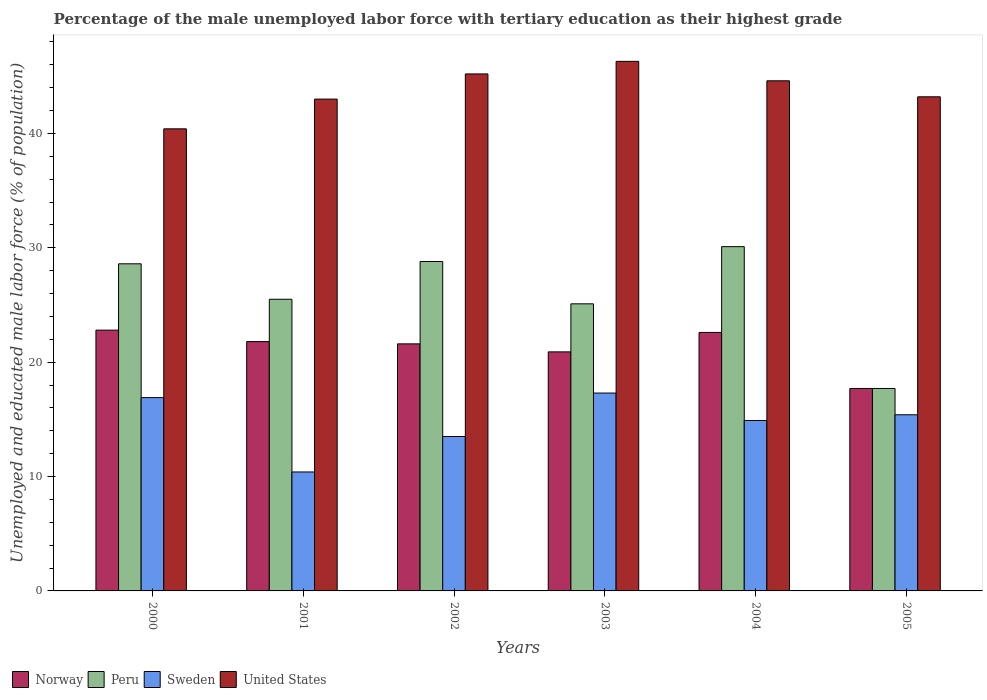How many groups of bars are there?
Ensure brevity in your answer.  6. Are the number of bars per tick equal to the number of legend labels?
Offer a terse response. Yes. Are the number of bars on each tick of the X-axis equal?
Provide a short and direct response. Yes. How many bars are there on the 1st tick from the left?
Ensure brevity in your answer.  4. How many bars are there on the 4th tick from the right?
Give a very brief answer. 4. What is the percentage of the unemployed male labor force with tertiary education in United States in 2000?
Offer a very short reply. 40.4. Across all years, what is the maximum percentage of the unemployed male labor force with tertiary education in Peru?
Provide a short and direct response. 30.1. Across all years, what is the minimum percentage of the unemployed male labor force with tertiary education in Sweden?
Provide a short and direct response. 10.4. What is the total percentage of the unemployed male labor force with tertiary education in Peru in the graph?
Your response must be concise. 155.8. What is the difference between the percentage of the unemployed male labor force with tertiary education in Sweden in 2001 and that in 2003?
Your answer should be very brief. -6.9. What is the difference between the percentage of the unemployed male labor force with tertiary education in Sweden in 2000 and the percentage of the unemployed male labor force with tertiary education in United States in 2002?
Your answer should be very brief. -28.3. What is the average percentage of the unemployed male labor force with tertiary education in United States per year?
Offer a very short reply. 43.78. In the year 2004, what is the difference between the percentage of the unemployed male labor force with tertiary education in Sweden and percentage of the unemployed male labor force with tertiary education in United States?
Make the answer very short. -29.7. In how many years, is the percentage of the unemployed male labor force with tertiary education in Peru greater than 26 %?
Provide a succinct answer. 3. What is the ratio of the percentage of the unemployed male labor force with tertiary education in Norway in 2000 to that in 2004?
Your answer should be very brief. 1.01. Is the difference between the percentage of the unemployed male labor force with tertiary education in Sweden in 2004 and 2005 greater than the difference between the percentage of the unemployed male labor force with tertiary education in United States in 2004 and 2005?
Offer a terse response. No. What is the difference between the highest and the second highest percentage of the unemployed male labor force with tertiary education in United States?
Provide a succinct answer. 1.1. What is the difference between the highest and the lowest percentage of the unemployed male labor force with tertiary education in United States?
Your answer should be compact. 5.9. In how many years, is the percentage of the unemployed male labor force with tertiary education in Peru greater than the average percentage of the unemployed male labor force with tertiary education in Peru taken over all years?
Your answer should be compact. 3. Is the sum of the percentage of the unemployed male labor force with tertiary education in Norway in 2001 and 2005 greater than the maximum percentage of the unemployed male labor force with tertiary education in United States across all years?
Your answer should be compact. No. Is it the case that in every year, the sum of the percentage of the unemployed male labor force with tertiary education in United States and percentage of the unemployed male labor force with tertiary education in Sweden is greater than the sum of percentage of the unemployed male labor force with tertiary education in Peru and percentage of the unemployed male labor force with tertiary education in Norway?
Ensure brevity in your answer.  No. What does the 1st bar from the left in 2002 represents?
Give a very brief answer. Norway. What does the 3rd bar from the right in 2002 represents?
Your answer should be compact. Peru. Is it the case that in every year, the sum of the percentage of the unemployed male labor force with tertiary education in Norway and percentage of the unemployed male labor force with tertiary education in United States is greater than the percentage of the unemployed male labor force with tertiary education in Peru?
Provide a succinct answer. Yes. How many bars are there?
Keep it short and to the point. 24. Are all the bars in the graph horizontal?
Ensure brevity in your answer.  No. How many years are there in the graph?
Offer a very short reply. 6. What is the difference between two consecutive major ticks on the Y-axis?
Provide a succinct answer. 10. Where does the legend appear in the graph?
Your response must be concise. Bottom left. How many legend labels are there?
Make the answer very short. 4. What is the title of the graph?
Offer a very short reply. Percentage of the male unemployed labor force with tertiary education as their highest grade. What is the label or title of the Y-axis?
Your answer should be compact. Unemployed and educated male labor force (% of population). What is the Unemployed and educated male labor force (% of population) in Norway in 2000?
Give a very brief answer. 22.8. What is the Unemployed and educated male labor force (% of population) in Peru in 2000?
Give a very brief answer. 28.6. What is the Unemployed and educated male labor force (% of population) of Sweden in 2000?
Ensure brevity in your answer.  16.9. What is the Unemployed and educated male labor force (% of population) of United States in 2000?
Ensure brevity in your answer.  40.4. What is the Unemployed and educated male labor force (% of population) of Norway in 2001?
Make the answer very short. 21.8. What is the Unemployed and educated male labor force (% of population) in Sweden in 2001?
Give a very brief answer. 10.4. What is the Unemployed and educated male labor force (% of population) in Norway in 2002?
Provide a short and direct response. 21.6. What is the Unemployed and educated male labor force (% of population) of Peru in 2002?
Provide a succinct answer. 28.8. What is the Unemployed and educated male labor force (% of population) in United States in 2002?
Your answer should be compact. 45.2. What is the Unemployed and educated male labor force (% of population) of Norway in 2003?
Offer a very short reply. 20.9. What is the Unemployed and educated male labor force (% of population) in Peru in 2003?
Your answer should be compact. 25.1. What is the Unemployed and educated male labor force (% of population) of Sweden in 2003?
Offer a terse response. 17.3. What is the Unemployed and educated male labor force (% of population) of United States in 2003?
Your answer should be compact. 46.3. What is the Unemployed and educated male labor force (% of population) of Norway in 2004?
Your response must be concise. 22.6. What is the Unemployed and educated male labor force (% of population) of Peru in 2004?
Provide a short and direct response. 30.1. What is the Unemployed and educated male labor force (% of population) of Sweden in 2004?
Your answer should be compact. 14.9. What is the Unemployed and educated male labor force (% of population) in United States in 2004?
Offer a very short reply. 44.6. What is the Unemployed and educated male labor force (% of population) of Norway in 2005?
Provide a succinct answer. 17.7. What is the Unemployed and educated male labor force (% of population) in Peru in 2005?
Your answer should be very brief. 17.7. What is the Unemployed and educated male labor force (% of population) in Sweden in 2005?
Your response must be concise. 15.4. What is the Unemployed and educated male labor force (% of population) in United States in 2005?
Give a very brief answer. 43.2. Across all years, what is the maximum Unemployed and educated male labor force (% of population) in Norway?
Provide a succinct answer. 22.8. Across all years, what is the maximum Unemployed and educated male labor force (% of population) of Peru?
Your answer should be very brief. 30.1. Across all years, what is the maximum Unemployed and educated male labor force (% of population) of Sweden?
Your response must be concise. 17.3. Across all years, what is the maximum Unemployed and educated male labor force (% of population) in United States?
Provide a succinct answer. 46.3. Across all years, what is the minimum Unemployed and educated male labor force (% of population) in Norway?
Your response must be concise. 17.7. Across all years, what is the minimum Unemployed and educated male labor force (% of population) in Peru?
Your answer should be very brief. 17.7. Across all years, what is the minimum Unemployed and educated male labor force (% of population) in Sweden?
Keep it short and to the point. 10.4. Across all years, what is the minimum Unemployed and educated male labor force (% of population) of United States?
Provide a succinct answer. 40.4. What is the total Unemployed and educated male labor force (% of population) in Norway in the graph?
Your answer should be compact. 127.4. What is the total Unemployed and educated male labor force (% of population) of Peru in the graph?
Offer a terse response. 155.8. What is the total Unemployed and educated male labor force (% of population) of Sweden in the graph?
Ensure brevity in your answer.  88.4. What is the total Unemployed and educated male labor force (% of population) in United States in the graph?
Keep it short and to the point. 262.7. What is the difference between the Unemployed and educated male labor force (% of population) in Sweden in 2000 and that in 2001?
Give a very brief answer. 6.5. What is the difference between the Unemployed and educated male labor force (% of population) in Peru in 2000 and that in 2002?
Offer a terse response. -0.2. What is the difference between the Unemployed and educated male labor force (% of population) of Sweden in 2000 and that in 2002?
Ensure brevity in your answer.  3.4. What is the difference between the Unemployed and educated male labor force (% of population) in United States in 2000 and that in 2002?
Your answer should be compact. -4.8. What is the difference between the Unemployed and educated male labor force (% of population) in Norway in 2000 and that in 2003?
Your answer should be compact. 1.9. What is the difference between the Unemployed and educated male labor force (% of population) of Peru in 2000 and that in 2003?
Give a very brief answer. 3.5. What is the difference between the Unemployed and educated male labor force (% of population) in United States in 2000 and that in 2003?
Provide a short and direct response. -5.9. What is the difference between the Unemployed and educated male labor force (% of population) of Peru in 2000 and that in 2005?
Provide a succinct answer. 10.9. What is the difference between the Unemployed and educated male labor force (% of population) of Sweden in 2000 and that in 2005?
Offer a very short reply. 1.5. What is the difference between the Unemployed and educated male labor force (% of population) of Norway in 2001 and that in 2002?
Offer a terse response. 0.2. What is the difference between the Unemployed and educated male labor force (% of population) in Peru in 2001 and that in 2002?
Your answer should be compact. -3.3. What is the difference between the Unemployed and educated male labor force (% of population) in Sweden in 2001 and that in 2002?
Make the answer very short. -3.1. What is the difference between the Unemployed and educated male labor force (% of population) in United States in 2001 and that in 2002?
Give a very brief answer. -2.2. What is the difference between the Unemployed and educated male labor force (% of population) in Norway in 2001 and that in 2003?
Offer a terse response. 0.9. What is the difference between the Unemployed and educated male labor force (% of population) of Sweden in 2001 and that in 2003?
Make the answer very short. -6.9. What is the difference between the Unemployed and educated male labor force (% of population) of Norway in 2001 and that in 2004?
Your answer should be compact. -0.8. What is the difference between the Unemployed and educated male labor force (% of population) of Sweden in 2001 and that in 2004?
Provide a succinct answer. -4.5. What is the difference between the Unemployed and educated male labor force (% of population) in Norway in 2001 and that in 2005?
Offer a very short reply. 4.1. What is the difference between the Unemployed and educated male labor force (% of population) in United States in 2001 and that in 2005?
Make the answer very short. -0.2. What is the difference between the Unemployed and educated male labor force (% of population) in Peru in 2002 and that in 2003?
Keep it short and to the point. 3.7. What is the difference between the Unemployed and educated male labor force (% of population) of Sweden in 2002 and that in 2003?
Your answer should be compact. -3.8. What is the difference between the Unemployed and educated male labor force (% of population) in United States in 2002 and that in 2003?
Provide a succinct answer. -1.1. What is the difference between the Unemployed and educated male labor force (% of population) in Sweden in 2002 and that in 2004?
Make the answer very short. -1.4. What is the difference between the Unemployed and educated male labor force (% of population) in United States in 2002 and that in 2004?
Provide a short and direct response. 0.6. What is the difference between the Unemployed and educated male labor force (% of population) of Norway in 2002 and that in 2005?
Offer a terse response. 3.9. What is the difference between the Unemployed and educated male labor force (% of population) of United States in 2002 and that in 2005?
Ensure brevity in your answer.  2. What is the difference between the Unemployed and educated male labor force (% of population) of Norway in 2003 and that in 2004?
Your answer should be compact. -1.7. What is the difference between the Unemployed and educated male labor force (% of population) of Sweden in 2003 and that in 2004?
Your answer should be compact. 2.4. What is the difference between the Unemployed and educated male labor force (% of population) of United States in 2003 and that in 2005?
Ensure brevity in your answer.  3.1. What is the difference between the Unemployed and educated male labor force (% of population) in Norway in 2004 and that in 2005?
Offer a terse response. 4.9. What is the difference between the Unemployed and educated male labor force (% of population) in Sweden in 2004 and that in 2005?
Ensure brevity in your answer.  -0.5. What is the difference between the Unemployed and educated male labor force (% of population) in Norway in 2000 and the Unemployed and educated male labor force (% of population) in Peru in 2001?
Provide a succinct answer. -2.7. What is the difference between the Unemployed and educated male labor force (% of population) of Norway in 2000 and the Unemployed and educated male labor force (% of population) of United States in 2001?
Your response must be concise. -20.2. What is the difference between the Unemployed and educated male labor force (% of population) of Peru in 2000 and the Unemployed and educated male labor force (% of population) of United States in 2001?
Offer a very short reply. -14.4. What is the difference between the Unemployed and educated male labor force (% of population) in Sweden in 2000 and the Unemployed and educated male labor force (% of population) in United States in 2001?
Make the answer very short. -26.1. What is the difference between the Unemployed and educated male labor force (% of population) of Norway in 2000 and the Unemployed and educated male labor force (% of population) of Peru in 2002?
Provide a succinct answer. -6. What is the difference between the Unemployed and educated male labor force (% of population) of Norway in 2000 and the Unemployed and educated male labor force (% of population) of Sweden in 2002?
Your answer should be very brief. 9.3. What is the difference between the Unemployed and educated male labor force (% of population) of Norway in 2000 and the Unemployed and educated male labor force (% of population) of United States in 2002?
Offer a very short reply. -22.4. What is the difference between the Unemployed and educated male labor force (% of population) of Peru in 2000 and the Unemployed and educated male labor force (% of population) of United States in 2002?
Your answer should be compact. -16.6. What is the difference between the Unemployed and educated male labor force (% of population) of Sweden in 2000 and the Unemployed and educated male labor force (% of population) of United States in 2002?
Give a very brief answer. -28.3. What is the difference between the Unemployed and educated male labor force (% of population) of Norway in 2000 and the Unemployed and educated male labor force (% of population) of Sweden in 2003?
Your response must be concise. 5.5. What is the difference between the Unemployed and educated male labor force (% of population) in Norway in 2000 and the Unemployed and educated male labor force (% of population) in United States in 2003?
Keep it short and to the point. -23.5. What is the difference between the Unemployed and educated male labor force (% of population) of Peru in 2000 and the Unemployed and educated male labor force (% of population) of United States in 2003?
Provide a succinct answer. -17.7. What is the difference between the Unemployed and educated male labor force (% of population) in Sweden in 2000 and the Unemployed and educated male labor force (% of population) in United States in 2003?
Provide a succinct answer. -29.4. What is the difference between the Unemployed and educated male labor force (% of population) of Norway in 2000 and the Unemployed and educated male labor force (% of population) of Sweden in 2004?
Make the answer very short. 7.9. What is the difference between the Unemployed and educated male labor force (% of population) in Norway in 2000 and the Unemployed and educated male labor force (% of population) in United States in 2004?
Make the answer very short. -21.8. What is the difference between the Unemployed and educated male labor force (% of population) in Peru in 2000 and the Unemployed and educated male labor force (% of population) in United States in 2004?
Offer a very short reply. -16. What is the difference between the Unemployed and educated male labor force (% of population) of Sweden in 2000 and the Unemployed and educated male labor force (% of population) of United States in 2004?
Offer a terse response. -27.7. What is the difference between the Unemployed and educated male labor force (% of population) in Norway in 2000 and the Unemployed and educated male labor force (% of population) in Peru in 2005?
Your answer should be very brief. 5.1. What is the difference between the Unemployed and educated male labor force (% of population) of Norway in 2000 and the Unemployed and educated male labor force (% of population) of United States in 2005?
Provide a short and direct response. -20.4. What is the difference between the Unemployed and educated male labor force (% of population) in Peru in 2000 and the Unemployed and educated male labor force (% of population) in Sweden in 2005?
Make the answer very short. 13.2. What is the difference between the Unemployed and educated male labor force (% of population) in Peru in 2000 and the Unemployed and educated male labor force (% of population) in United States in 2005?
Provide a succinct answer. -14.6. What is the difference between the Unemployed and educated male labor force (% of population) in Sweden in 2000 and the Unemployed and educated male labor force (% of population) in United States in 2005?
Make the answer very short. -26.3. What is the difference between the Unemployed and educated male labor force (% of population) of Norway in 2001 and the Unemployed and educated male labor force (% of population) of United States in 2002?
Your answer should be compact. -23.4. What is the difference between the Unemployed and educated male labor force (% of population) of Peru in 2001 and the Unemployed and educated male labor force (% of population) of Sweden in 2002?
Offer a very short reply. 12. What is the difference between the Unemployed and educated male labor force (% of population) of Peru in 2001 and the Unemployed and educated male labor force (% of population) of United States in 2002?
Ensure brevity in your answer.  -19.7. What is the difference between the Unemployed and educated male labor force (% of population) of Sweden in 2001 and the Unemployed and educated male labor force (% of population) of United States in 2002?
Offer a terse response. -34.8. What is the difference between the Unemployed and educated male labor force (% of population) of Norway in 2001 and the Unemployed and educated male labor force (% of population) of Peru in 2003?
Your response must be concise. -3.3. What is the difference between the Unemployed and educated male labor force (% of population) of Norway in 2001 and the Unemployed and educated male labor force (% of population) of United States in 2003?
Offer a terse response. -24.5. What is the difference between the Unemployed and educated male labor force (% of population) in Peru in 2001 and the Unemployed and educated male labor force (% of population) in United States in 2003?
Offer a terse response. -20.8. What is the difference between the Unemployed and educated male labor force (% of population) in Sweden in 2001 and the Unemployed and educated male labor force (% of population) in United States in 2003?
Provide a succinct answer. -35.9. What is the difference between the Unemployed and educated male labor force (% of population) of Norway in 2001 and the Unemployed and educated male labor force (% of population) of Peru in 2004?
Provide a short and direct response. -8.3. What is the difference between the Unemployed and educated male labor force (% of population) of Norway in 2001 and the Unemployed and educated male labor force (% of population) of Sweden in 2004?
Offer a terse response. 6.9. What is the difference between the Unemployed and educated male labor force (% of population) in Norway in 2001 and the Unemployed and educated male labor force (% of population) in United States in 2004?
Give a very brief answer. -22.8. What is the difference between the Unemployed and educated male labor force (% of population) in Peru in 2001 and the Unemployed and educated male labor force (% of population) in United States in 2004?
Provide a succinct answer. -19.1. What is the difference between the Unemployed and educated male labor force (% of population) in Sweden in 2001 and the Unemployed and educated male labor force (% of population) in United States in 2004?
Your answer should be very brief. -34.2. What is the difference between the Unemployed and educated male labor force (% of population) in Norway in 2001 and the Unemployed and educated male labor force (% of population) in Sweden in 2005?
Your answer should be compact. 6.4. What is the difference between the Unemployed and educated male labor force (% of population) of Norway in 2001 and the Unemployed and educated male labor force (% of population) of United States in 2005?
Keep it short and to the point. -21.4. What is the difference between the Unemployed and educated male labor force (% of population) of Peru in 2001 and the Unemployed and educated male labor force (% of population) of Sweden in 2005?
Your answer should be very brief. 10.1. What is the difference between the Unemployed and educated male labor force (% of population) in Peru in 2001 and the Unemployed and educated male labor force (% of population) in United States in 2005?
Provide a short and direct response. -17.7. What is the difference between the Unemployed and educated male labor force (% of population) in Sweden in 2001 and the Unemployed and educated male labor force (% of population) in United States in 2005?
Provide a short and direct response. -32.8. What is the difference between the Unemployed and educated male labor force (% of population) in Norway in 2002 and the Unemployed and educated male labor force (% of population) in Peru in 2003?
Ensure brevity in your answer.  -3.5. What is the difference between the Unemployed and educated male labor force (% of population) of Norway in 2002 and the Unemployed and educated male labor force (% of population) of United States in 2003?
Keep it short and to the point. -24.7. What is the difference between the Unemployed and educated male labor force (% of population) in Peru in 2002 and the Unemployed and educated male labor force (% of population) in United States in 2003?
Your answer should be very brief. -17.5. What is the difference between the Unemployed and educated male labor force (% of population) of Sweden in 2002 and the Unemployed and educated male labor force (% of population) of United States in 2003?
Provide a short and direct response. -32.8. What is the difference between the Unemployed and educated male labor force (% of population) of Norway in 2002 and the Unemployed and educated male labor force (% of population) of Peru in 2004?
Your response must be concise. -8.5. What is the difference between the Unemployed and educated male labor force (% of population) in Norway in 2002 and the Unemployed and educated male labor force (% of population) in Sweden in 2004?
Your response must be concise. 6.7. What is the difference between the Unemployed and educated male labor force (% of population) of Norway in 2002 and the Unemployed and educated male labor force (% of population) of United States in 2004?
Keep it short and to the point. -23. What is the difference between the Unemployed and educated male labor force (% of population) in Peru in 2002 and the Unemployed and educated male labor force (% of population) in United States in 2004?
Give a very brief answer. -15.8. What is the difference between the Unemployed and educated male labor force (% of population) in Sweden in 2002 and the Unemployed and educated male labor force (% of population) in United States in 2004?
Ensure brevity in your answer.  -31.1. What is the difference between the Unemployed and educated male labor force (% of population) of Norway in 2002 and the Unemployed and educated male labor force (% of population) of Sweden in 2005?
Make the answer very short. 6.2. What is the difference between the Unemployed and educated male labor force (% of population) in Norway in 2002 and the Unemployed and educated male labor force (% of population) in United States in 2005?
Give a very brief answer. -21.6. What is the difference between the Unemployed and educated male labor force (% of population) in Peru in 2002 and the Unemployed and educated male labor force (% of population) in United States in 2005?
Offer a very short reply. -14.4. What is the difference between the Unemployed and educated male labor force (% of population) of Sweden in 2002 and the Unemployed and educated male labor force (% of population) of United States in 2005?
Make the answer very short. -29.7. What is the difference between the Unemployed and educated male labor force (% of population) of Norway in 2003 and the Unemployed and educated male labor force (% of population) of Peru in 2004?
Ensure brevity in your answer.  -9.2. What is the difference between the Unemployed and educated male labor force (% of population) in Norway in 2003 and the Unemployed and educated male labor force (% of population) in United States in 2004?
Ensure brevity in your answer.  -23.7. What is the difference between the Unemployed and educated male labor force (% of population) of Peru in 2003 and the Unemployed and educated male labor force (% of population) of Sweden in 2004?
Keep it short and to the point. 10.2. What is the difference between the Unemployed and educated male labor force (% of population) in Peru in 2003 and the Unemployed and educated male labor force (% of population) in United States in 2004?
Your response must be concise. -19.5. What is the difference between the Unemployed and educated male labor force (% of population) in Sweden in 2003 and the Unemployed and educated male labor force (% of population) in United States in 2004?
Your response must be concise. -27.3. What is the difference between the Unemployed and educated male labor force (% of population) in Norway in 2003 and the Unemployed and educated male labor force (% of population) in Peru in 2005?
Your answer should be compact. 3.2. What is the difference between the Unemployed and educated male labor force (% of population) in Norway in 2003 and the Unemployed and educated male labor force (% of population) in Sweden in 2005?
Your response must be concise. 5.5. What is the difference between the Unemployed and educated male labor force (% of population) in Norway in 2003 and the Unemployed and educated male labor force (% of population) in United States in 2005?
Your response must be concise. -22.3. What is the difference between the Unemployed and educated male labor force (% of population) in Peru in 2003 and the Unemployed and educated male labor force (% of population) in Sweden in 2005?
Provide a short and direct response. 9.7. What is the difference between the Unemployed and educated male labor force (% of population) in Peru in 2003 and the Unemployed and educated male labor force (% of population) in United States in 2005?
Keep it short and to the point. -18.1. What is the difference between the Unemployed and educated male labor force (% of population) in Sweden in 2003 and the Unemployed and educated male labor force (% of population) in United States in 2005?
Your answer should be very brief. -25.9. What is the difference between the Unemployed and educated male labor force (% of population) of Norway in 2004 and the Unemployed and educated male labor force (% of population) of United States in 2005?
Ensure brevity in your answer.  -20.6. What is the difference between the Unemployed and educated male labor force (% of population) of Peru in 2004 and the Unemployed and educated male labor force (% of population) of Sweden in 2005?
Make the answer very short. 14.7. What is the difference between the Unemployed and educated male labor force (% of population) in Peru in 2004 and the Unemployed and educated male labor force (% of population) in United States in 2005?
Provide a succinct answer. -13.1. What is the difference between the Unemployed and educated male labor force (% of population) in Sweden in 2004 and the Unemployed and educated male labor force (% of population) in United States in 2005?
Ensure brevity in your answer.  -28.3. What is the average Unemployed and educated male labor force (% of population) in Norway per year?
Your response must be concise. 21.23. What is the average Unemployed and educated male labor force (% of population) in Peru per year?
Your response must be concise. 25.97. What is the average Unemployed and educated male labor force (% of population) of Sweden per year?
Your response must be concise. 14.73. What is the average Unemployed and educated male labor force (% of population) in United States per year?
Offer a very short reply. 43.78. In the year 2000, what is the difference between the Unemployed and educated male labor force (% of population) in Norway and Unemployed and educated male labor force (% of population) in Peru?
Provide a short and direct response. -5.8. In the year 2000, what is the difference between the Unemployed and educated male labor force (% of population) in Norway and Unemployed and educated male labor force (% of population) in Sweden?
Offer a terse response. 5.9. In the year 2000, what is the difference between the Unemployed and educated male labor force (% of population) of Norway and Unemployed and educated male labor force (% of population) of United States?
Keep it short and to the point. -17.6. In the year 2000, what is the difference between the Unemployed and educated male labor force (% of population) in Peru and Unemployed and educated male labor force (% of population) in Sweden?
Provide a short and direct response. 11.7. In the year 2000, what is the difference between the Unemployed and educated male labor force (% of population) of Sweden and Unemployed and educated male labor force (% of population) of United States?
Your response must be concise. -23.5. In the year 2001, what is the difference between the Unemployed and educated male labor force (% of population) of Norway and Unemployed and educated male labor force (% of population) of Peru?
Offer a terse response. -3.7. In the year 2001, what is the difference between the Unemployed and educated male labor force (% of population) in Norway and Unemployed and educated male labor force (% of population) in United States?
Keep it short and to the point. -21.2. In the year 2001, what is the difference between the Unemployed and educated male labor force (% of population) of Peru and Unemployed and educated male labor force (% of population) of United States?
Keep it short and to the point. -17.5. In the year 2001, what is the difference between the Unemployed and educated male labor force (% of population) in Sweden and Unemployed and educated male labor force (% of population) in United States?
Offer a terse response. -32.6. In the year 2002, what is the difference between the Unemployed and educated male labor force (% of population) in Norway and Unemployed and educated male labor force (% of population) in Peru?
Your answer should be compact. -7.2. In the year 2002, what is the difference between the Unemployed and educated male labor force (% of population) in Norway and Unemployed and educated male labor force (% of population) in United States?
Offer a very short reply. -23.6. In the year 2002, what is the difference between the Unemployed and educated male labor force (% of population) of Peru and Unemployed and educated male labor force (% of population) of Sweden?
Offer a very short reply. 15.3. In the year 2002, what is the difference between the Unemployed and educated male labor force (% of population) in Peru and Unemployed and educated male labor force (% of population) in United States?
Offer a terse response. -16.4. In the year 2002, what is the difference between the Unemployed and educated male labor force (% of population) of Sweden and Unemployed and educated male labor force (% of population) of United States?
Your answer should be compact. -31.7. In the year 2003, what is the difference between the Unemployed and educated male labor force (% of population) of Norway and Unemployed and educated male labor force (% of population) of United States?
Offer a very short reply. -25.4. In the year 2003, what is the difference between the Unemployed and educated male labor force (% of population) in Peru and Unemployed and educated male labor force (% of population) in United States?
Give a very brief answer. -21.2. In the year 2004, what is the difference between the Unemployed and educated male labor force (% of population) in Norway and Unemployed and educated male labor force (% of population) in Sweden?
Make the answer very short. 7.7. In the year 2004, what is the difference between the Unemployed and educated male labor force (% of population) in Norway and Unemployed and educated male labor force (% of population) in United States?
Ensure brevity in your answer.  -22. In the year 2004, what is the difference between the Unemployed and educated male labor force (% of population) in Peru and Unemployed and educated male labor force (% of population) in Sweden?
Your answer should be compact. 15.2. In the year 2004, what is the difference between the Unemployed and educated male labor force (% of population) in Peru and Unemployed and educated male labor force (% of population) in United States?
Offer a terse response. -14.5. In the year 2004, what is the difference between the Unemployed and educated male labor force (% of population) in Sweden and Unemployed and educated male labor force (% of population) in United States?
Make the answer very short. -29.7. In the year 2005, what is the difference between the Unemployed and educated male labor force (% of population) in Norway and Unemployed and educated male labor force (% of population) in Sweden?
Your response must be concise. 2.3. In the year 2005, what is the difference between the Unemployed and educated male labor force (% of population) in Norway and Unemployed and educated male labor force (% of population) in United States?
Provide a short and direct response. -25.5. In the year 2005, what is the difference between the Unemployed and educated male labor force (% of population) in Peru and Unemployed and educated male labor force (% of population) in United States?
Make the answer very short. -25.5. In the year 2005, what is the difference between the Unemployed and educated male labor force (% of population) of Sweden and Unemployed and educated male labor force (% of population) of United States?
Make the answer very short. -27.8. What is the ratio of the Unemployed and educated male labor force (% of population) in Norway in 2000 to that in 2001?
Offer a terse response. 1.05. What is the ratio of the Unemployed and educated male labor force (% of population) of Peru in 2000 to that in 2001?
Your answer should be very brief. 1.12. What is the ratio of the Unemployed and educated male labor force (% of population) in Sweden in 2000 to that in 2001?
Your answer should be compact. 1.62. What is the ratio of the Unemployed and educated male labor force (% of population) in United States in 2000 to that in 2001?
Ensure brevity in your answer.  0.94. What is the ratio of the Unemployed and educated male labor force (% of population) in Norway in 2000 to that in 2002?
Keep it short and to the point. 1.06. What is the ratio of the Unemployed and educated male labor force (% of population) in Sweden in 2000 to that in 2002?
Keep it short and to the point. 1.25. What is the ratio of the Unemployed and educated male labor force (% of population) of United States in 2000 to that in 2002?
Your answer should be compact. 0.89. What is the ratio of the Unemployed and educated male labor force (% of population) in Peru in 2000 to that in 2003?
Ensure brevity in your answer.  1.14. What is the ratio of the Unemployed and educated male labor force (% of population) in Sweden in 2000 to that in 2003?
Your answer should be very brief. 0.98. What is the ratio of the Unemployed and educated male labor force (% of population) in United States in 2000 to that in 2003?
Your response must be concise. 0.87. What is the ratio of the Unemployed and educated male labor force (% of population) of Norway in 2000 to that in 2004?
Ensure brevity in your answer.  1.01. What is the ratio of the Unemployed and educated male labor force (% of population) of Peru in 2000 to that in 2004?
Offer a terse response. 0.95. What is the ratio of the Unemployed and educated male labor force (% of population) of Sweden in 2000 to that in 2004?
Your answer should be compact. 1.13. What is the ratio of the Unemployed and educated male labor force (% of population) in United States in 2000 to that in 2004?
Your response must be concise. 0.91. What is the ratio of the Unemployed and educated male labor force (% of population) of Norway in 2000 to that in 2005?
Offer a terse response. 1.29. What is the ratio of the Unemployed and educated male labor force (% of population) in Peru in 2000 to that in 2005?
Offer a terse response. 1.62. What is the ratio of the Unemployed and educated male labor force (% of population) in Sweden in 2000 to that in 2005?
Give a very brief answer. 1.1. What is the ratio of the Unemployed and educated male labor force (% of population) in United States in 2000 to that in 2005?
Your answer should be compact. 0.94. What is the ratio of the Unemployed and educated male labor force (% of population) of Norway in 2001 to that in 2002?
Your response must be concise. 1.01. What is the ratio of the Unemployed and educated male labor force (% of population) of Peru in 2001 to that in 2002?
Offer a very short reply. 0.89. What is the ratio of the Unemployed and educated male labor force (% of population) in Sweden in 2001 to that in 2002?
Your answer should be compact. 0.77. What is the ratio of the Unemployed and educated male labor force (% of population) in United States in 2001 to that in 2002?
Offer a very short reply. 0.95. What is the ratio of the Unemployed and educated male labor force (% of population) of Norway in 2001 to that in 2003?
Your answer should be compact. 1.04. What is the ratio of the Unemployed and educated male labor force (% of population) of Peru in 2001 to that in 2003?
Keep it short and to the point. 1.02. What is the ratio of the Unemployed and educated male labor force (% of population) in Sweden in 2001 to that in 2003?
Provide a succinct answer. 0.6. What is the ratio of the Unemployed and educated male labor force (% of population) in United States in 2001 to that in 2003?
Your answer should be compact. 0.93. What is the ratio of the Unemployed and educated male labor force (% of population) of Norway in 2001 to that in 2004?
Keep it short and to the point. 0.96. What is the ratio of the Unemployed and educated male labor force (% of population) in Peru in 2001 to that in 2004?
Your response must be concise. 0.85. What is the ratio of the Unemployed and educated male labor force (% of population) of Sweden in 2001 to that in 2004?
Ensure brevity in your answer.  0.7. What is the ratio of the Unemployed and educated male labor force (% of population) in United States in 2001 to that in 2004?
Provide a succinct answer. 0.96. What is the ratio of the Unemployed and educated male labor force (% of population) of Norway in 2001 to that in 2005?
Offer a terse response. 1.23. What is the ratio of the Unemployed and educated male labor force (% of population) in Peru in 2001 to that in 2005?
Offer a very short reply. 1.44. What is the ratio of the Unemployed and educated male labor force (% of population) of Sweden in 2001 to that in 2005?
Your answer should be very brief. 0.68. What is the ratio of the Unemployed and educated male labor force (% of population) of United States in 2001 to that in 2005?
Keep it short and to the point. 1. What is the ratio of the Unemployed and educated male labor force (% of population) in Norway in 2002 to that in 2003?
Ensure brevity in your answer.  1.03. What is the ratio of the Unemployed and educated male labor force (% of population) of Peru in 2002 to that in 2003?
Ensure brevity in your answer.  1.15. What is the ratio of the Unemployed and educated male labor force (% of population) in Sweden in 2002 to that in 2003?
Your answer should be very brief. 0.78. What is the ratio of the Unemployed and educated male labor force (% of population) in United States in 2002 to that in 2003?
Keep it short and to the point. 0.98. What is the ratio of the Unemployed and educated male labor force (% of population) in Norway in 2002 to that in 2004?
Your answer should be very brief. 0.96. What is the ratio of the Unemployed and educated male labor force (% of population) of Peru in 2002 to that in 2004?
Provide a succinct answer. 0.96. What is the ratio of the Unemployed and educated male labor force (% of population) of Sweden in 2002 to that in 2004?
Your response must be concise. 0.91. What is the ratio of the Unemployed and educated male labor force (% of population) in United States in 2002 to that in 2004?
Your answer should be very brief. 1.01. What is the ratio of the Unemployed and educated male labor force (% of population) of Norway in 2002 to that in 2005?
Give a very brief answer. 1.22. What is the ratio of the Unemployed and educated male labor force (% of population) of Peru in 2002 to that in 2005?
Your answer should be compact. 1.63. What is the ratio of the Unemployed and educated male labor force (% of population) of Sweden in 2002 to that in 2005?
Your answer should be very brief. 0.88. What is the ratio of the Unemployed and educated male labor force (% of population) of United States in 2002 to that in 2005?
Your answer should be compact. 1.05. What is the ratio of the Unemployed and educated male labor force (% of population) of Norway in 2003 to that in 2004?
Your answer should be compact. 0.92. What is the ratio of the Unemployed and educated male labor force (% of population) of Peru in 2003 to that in 2004?
Your response must be concise. 0.83. What is the ratio of the Unemployed and educated male labor force (% of population) of Sweden in 2003 to that in 2004?
Provide a short and direct response. 1.16. What is the ratio of the Unemployed and educated male labor force (% of population) of United States in 2003 to that in 2004?
Give a very brief answer. 1.04. What is the ratio of the Unemployed and educated male labor force (% of population) in Norway in 2003 to that in 2005?
Your answer should be very brief. 1.18. What is the ratio of the Unemployed and educated male labor force (% of population) in Peru in 2003 to that in 2005?
Your answer should be compact. 1.42. What is the ratio of the Unemployed and educated male labor force (% of population) of Sweden in 2003 to that in 2005?
Your answer should be very brief. 1.12. What is the ratio of the Unemployed and educated male labor force (% of population) in United States in 2003 to that in 2005?
Give a very brief answer. 1.07. What is the ratio of the Unemployed and educated male labor force (% of population) in Norway in 2004 to that in 2005?
Your answer should be compact. 1.28. What is the ratio of the Unemployed and educated male labor force (% of population) of Peru in 2004 to that in 2005?
Make the answer very short. 1.7. What is the ratio of the Unemployed and educated male labor force (% of population) in Sweden in 2004 to that in 2005?
Make the answer very short. 0.97. What is the ratio of the Unemployed and educated male labor force (% of population) in United States in 2004 to that in 2005?
Ensure brevity in your answer.  1.03. What is the difference between the highest and the second highest Unemployed and educated male labor force (% of population) of Peru?
Your answer should be very brief. 1.3. What is the difference between the highest and the second highest Unemployed and educated male labor force (% of population) in Sweden?
Offer a very short reply. 0.4. What is the difference between the highest and the lowest Unemployed and educated male labor force (% of population) in Peru?
Give a very brief answer. 12.4. What is the difference between the highest and the lowest Unemployed and educated male labor force (% of population) of United States?
Provide a succinct answer. 5.9. 